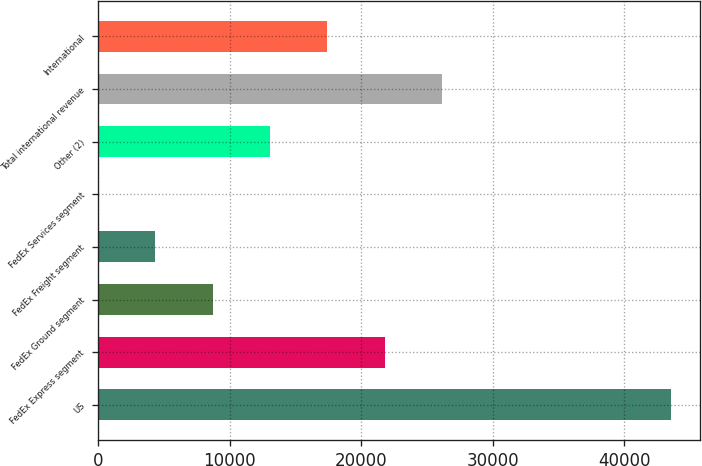Convert chart. <chart><loc_0><loc_0><loc_500><loc_500><bar_chart><fcel>US<fcel>FedEx Express segment<fcel>FedEx Ground segment<fcel>FedEx Freight segment<fcel>FedEx Services segment<fcel>Other (2)<fcel>Total international revenue<fcel>International<nl><fcel>43581<fcel>21792<fcel>8718.6<fcel>4360.8<fcel>3<fcel>13076.4<fcel>26149.8<fcel>17434.2<nl></chart> 